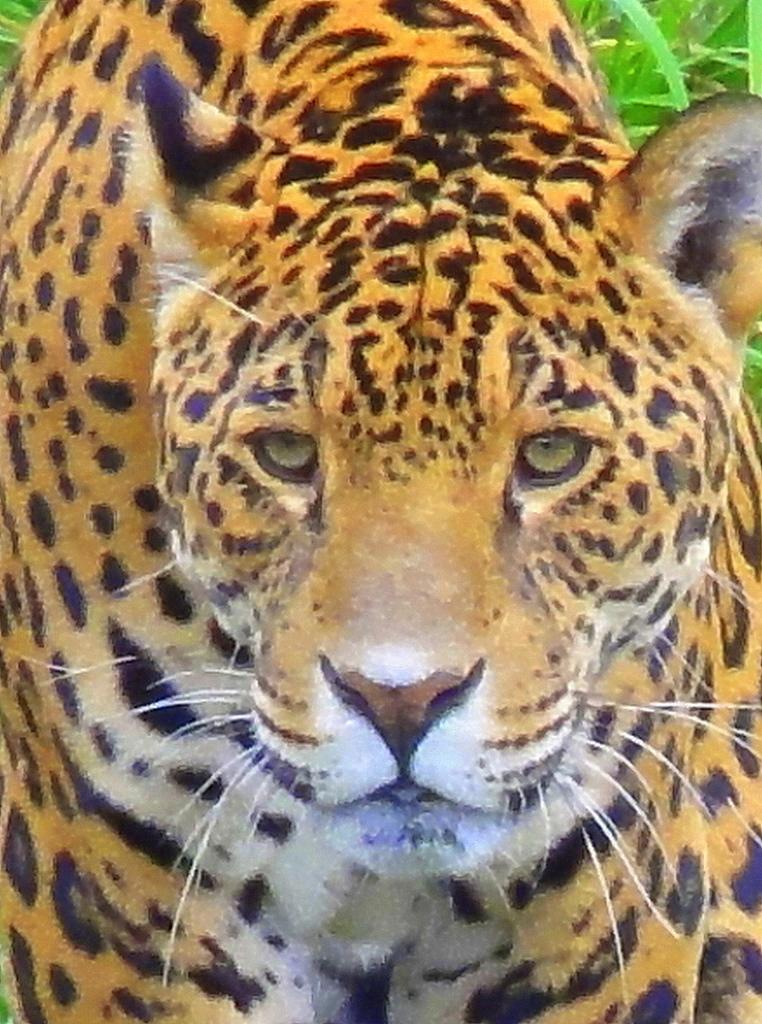What animal is in the foreground of the picture? There is a cheetah in the foreground of the picture. What type of vegetation can be seen in the background of the picture? There is grass in the background of the picture. How many sisters does the cheetah have in the picture? There are no sisters or any other animals mentioned in the image; it only features a cheetah. 